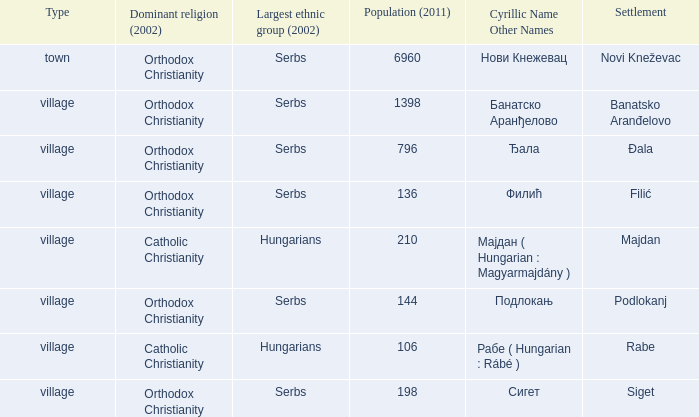Which settlement has the cyrillic name сигет?  Siget. Write the full table. {'header': ['Type', 'Dominant religion (2002)', 'Largest ethnic group (2002)', 'Population (2011)', 'Cyrillic Name Other Names', 'Settlement'], 'rows': [['town', 'Orthodox Christianity', 'Serbs', '6960', 'Нови Кнежевац', 'Novi Kneževac'], ['village', 'Orthodox Christianity', 'Serbs', '1398', 'Банатско Аранђелово', 'Banatsko Aranđelovo'], ['village', 'Orthodox Christianity', 'Serbs', '796', 'Ђала', 'Đala'], ['village', 'Orthodox Christianity', 'Serbs', '136', 'Филић', 'Filić'], ['village', 'Catholic Christianity', 'Hungarians', '210', 'Мајдан ( Hungarian : Magyarmajdány )', 'Majdan'], ['village', 'Orthodox Christianity', 'Serbs', '144', 'Подлокањ', 'Podlokanj'], ['village', 'Catholic Christianity', 'Hungarians', '106', 'Рабе ( Hungarian : Rábé )', 'Rabe'], ['village', 'Orthodox Christianity', 'Serbs', '198', 'Сигет', 'Siget']]} 